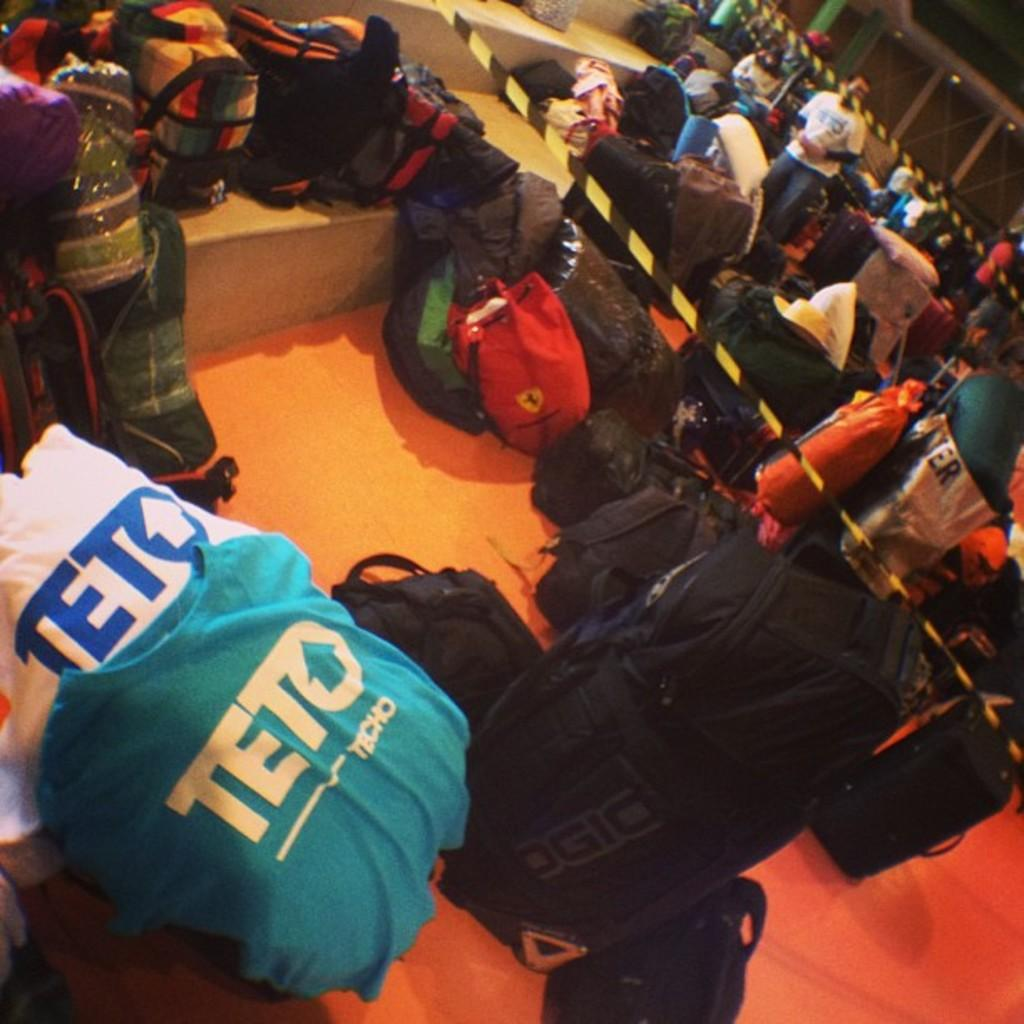Provide a one-sentence caption for the provided image. The Teto shirts are sitting around a stack of backpacks. 